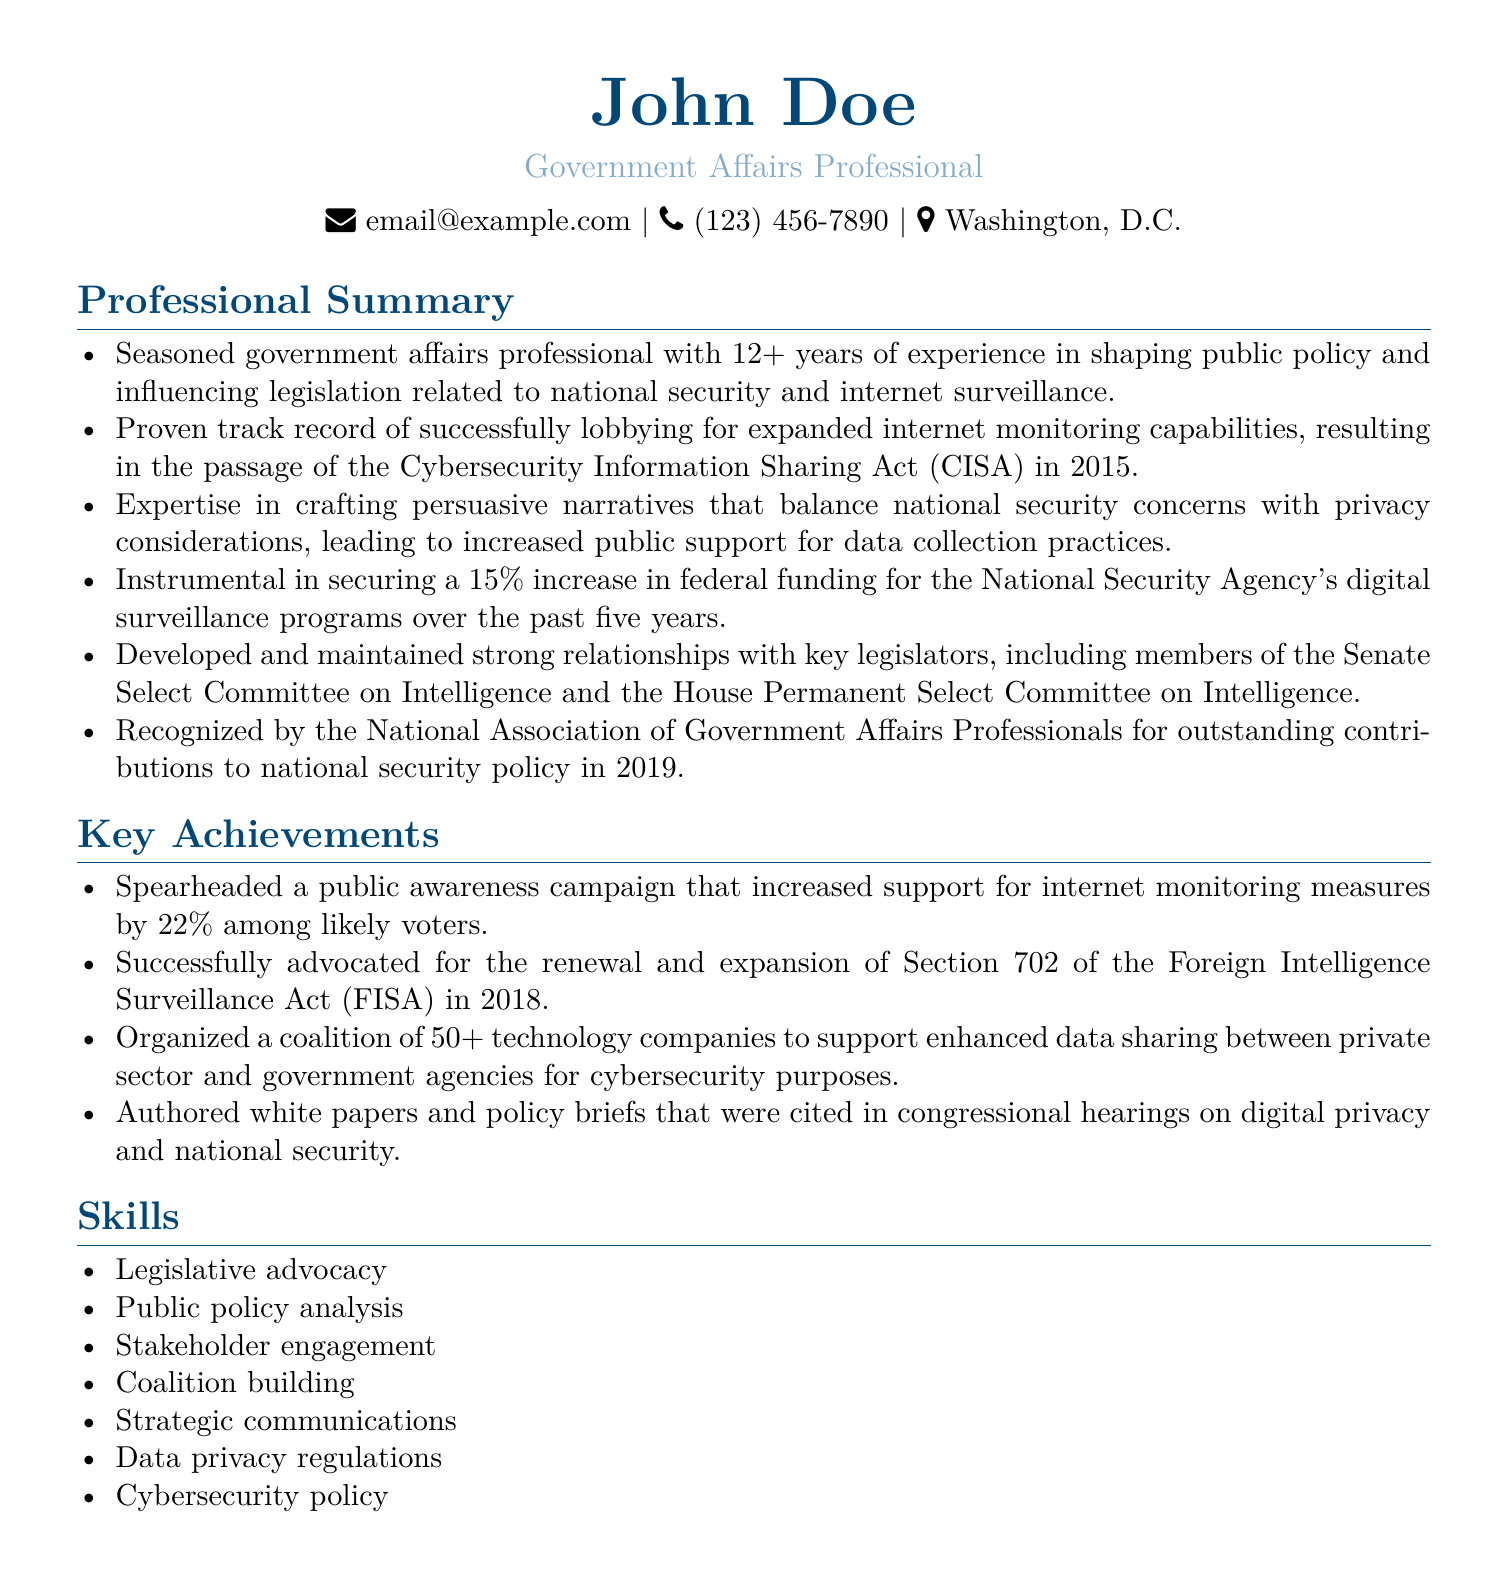What is the total years of experience? The total years of experience mentioned in the document is "12+" which indicates over twelve years.
Answer: 12+ What legislation did they successfully lobby for in 2015? The document states that there was successful lobbying for the "Cybersecurity Information Sharing Act (CISA)" in 2015.
Answer: Cybersecurity Information Sharing Act (CISA) What was the percentage increase in federal funding for the NSA's digital surveillance programs? The document highlights a "15%" increase in federal funding for these programs over five years.
Answer: 15% In which year was the National Association of Government Affairs Professionals recognition awarded? The document mentions that the recognition was awarded in "2019".
Answer: 2019 How many technology companies were organized into a coalition? The document mentions a coalition of "50+" technology companies.
Answer: 50+ What was the increase in public support for internet monitoring measures? The document states that support for internet monitoring measures was increased by "22%" among likely voters.
Answer: 22% What key committees did they maintain strong relationships with? The document specifies relationships with the "Senate Select Committee on Intelligence" and the "House Permanent Select Committee on Intelligence".
Answer: Senate Select Committee on Intelligence and House Permanent Select Committee on Intelligence What type of policy did they advocate for in 2018? The document indicates advocacy for the "renewal and expansion of Section 702 of the Foreign Intelligence Surveillance Act (FISA)".
Answer: renewal and expansion of Section 702 of the Foreign Intelligence Surveillance Act (FISA) What is one of their key skills? The document lists "Legislative advocacy" as one of the skills named.
Answer: Legislative advocacy 